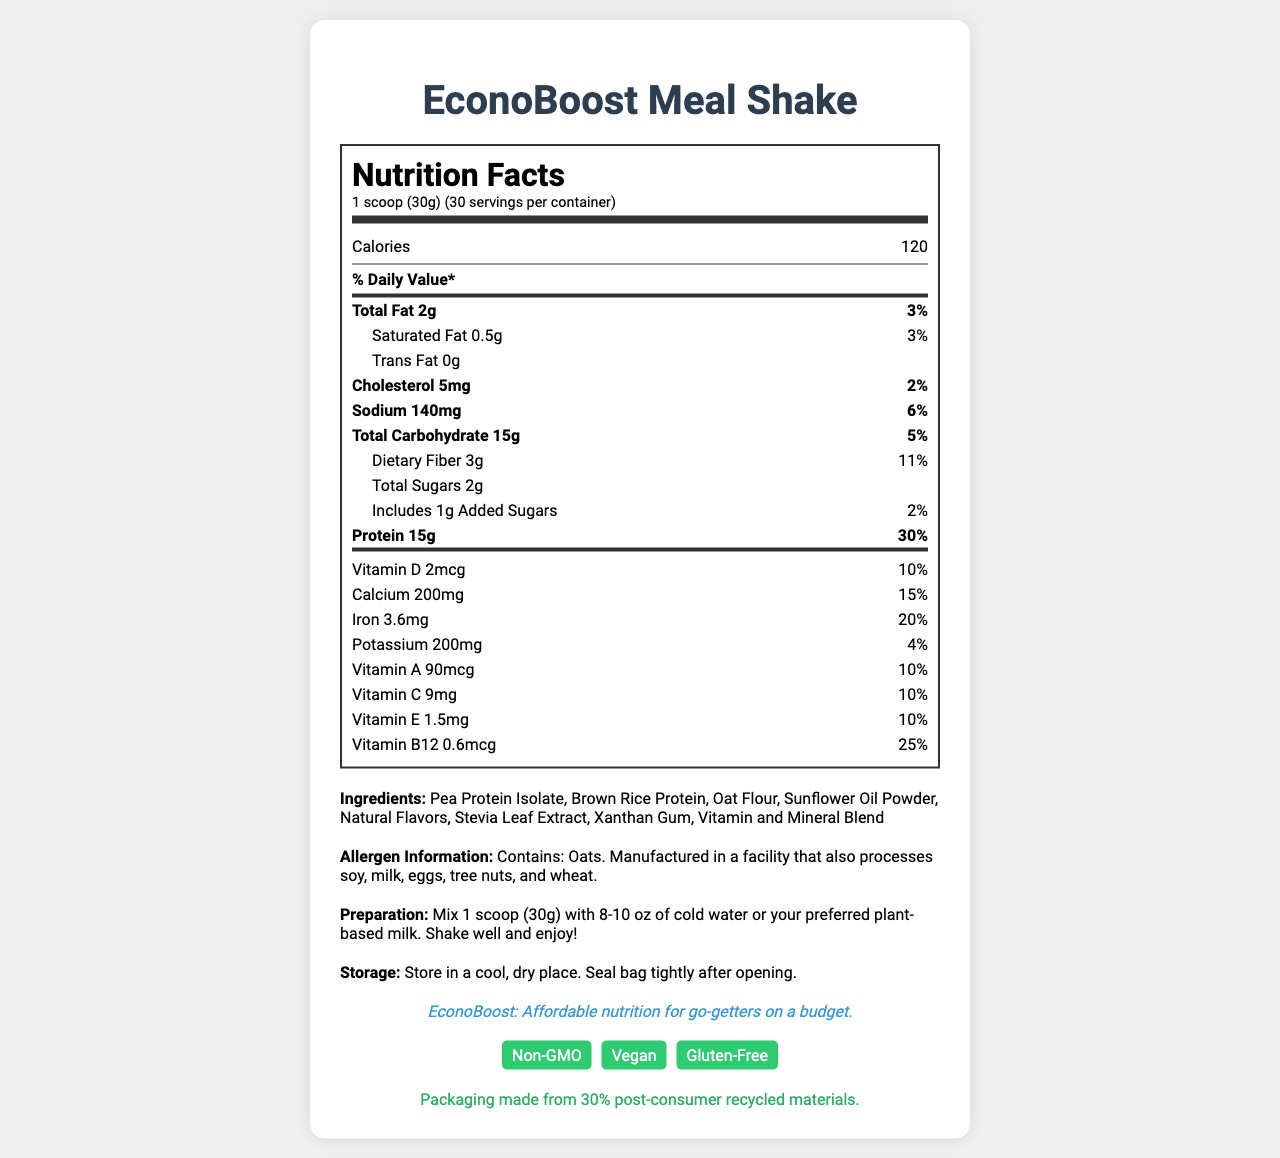What is the serving size of the EconoBoost Meal Shake? The serving size is explicitly mentioned in the Nutrition Facts Label as "1 scoop (30g)".
Answer: 1 scoop (30g) How many servings are there per container? The document states that there are 30 servings per container.
Answer: 30 What is the total fat content per serving? The total fat content per serving is given as 2g.
Answer: 2g How many grams of protein are in one serving? The Nutrition Facts Label lists 15g of protein per serving.
Answer: 15g What ingredient is listed second in the ingredients list? The second ingredient listed is Brown Rice Protein.
Answer: Brown Rice Protein Does this product contain any trans fat? The document states that the trans fat content is 0g.
Answer: No How much daily value of calcium does one serving provide? The daily value for calcium per serving is listed as 15%.
Answer: 15% Which of the following certifications does the EconoBoost Meal Shake not have? A. Organic B. Non-GMO C. Vegan D. Gluten-Free The document lists certifications as Non-GMO, Vegan, and Gluten-Free. It does not mention Organic.
Answer: A. Organic What is the recommended preparation instruction for this shake? A. Mix with 10-12 oz of water B. Mix with 8-10 oz of cold water or plant-based milk C. Mix with 6-8 oz of milk D. Mix with 12-14 oz of almond milk The document states to "Mix 1 scoop (30g) with 8-10 oz of cold water or your preferred plant-based milk."
Answer: B. Mix with 8-10 oz of cold water or plant-based milk Is the EconoBoost Meal Shake safe for someone who is allergic to tree nuts? The allergen information states it is manufactured in a facility that also processes tree nuts.
Answer: No Summarize the main idea of the document. The document provides detailed nutritional information, ingredients, allergen warnings, and instructions for the EconoBoost Meal Shake, emphasizing its affordability, nutritional value, and certifications like Non-GMO, Vegan, and Gluten-Free.
Answer: The EconoBoost Meal Shake is a budget-friendly, vegan, gluten-free meal replacement shake that provides various essential nutrients. It has a serving size of 1 scoop (30g) and offers 30 servings per container. Key nutrients are highlighted, including 15g of protein and a significant amount of vitamins and minerals. Instructions for preparation and storage are also included, along with allergen information and sustainability practices. Where can I buy the EconoBoost Meal Shake? The document does not provide any information on where the product can be purchased.
Answer: Cannot be determined 